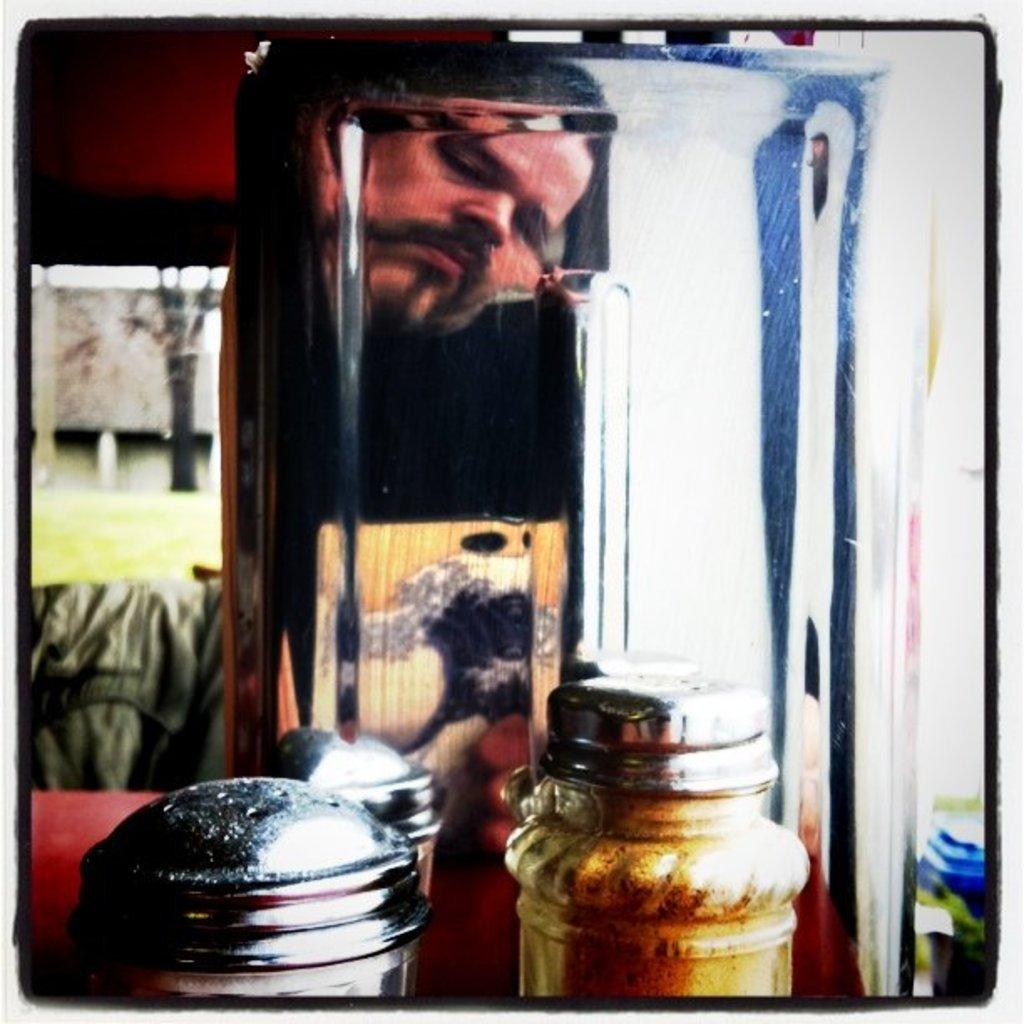What objects are on the table in the image? There are two small bottles on a table. Can you describe the person's face visible behind the bottles? Unfortunately, the facts provided do not give any details about the person's face. What might be the purpose of the small bottles on the table? The purpose of the small bottles cannot be determined from the provided facts. What type of apparel is the person wearing while making noise in the image? There is no information about the person's apparel or any noise in the image. 